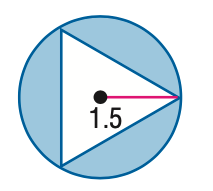Question: Find the area of the shaded region. Assume that all polygons that appear to be regular are regular. Round to the nearest tenth.
Choices:
A. 1.2
B. 4.1
C. 5.4
D. 7.1
Answer with the letter. Answer: B 